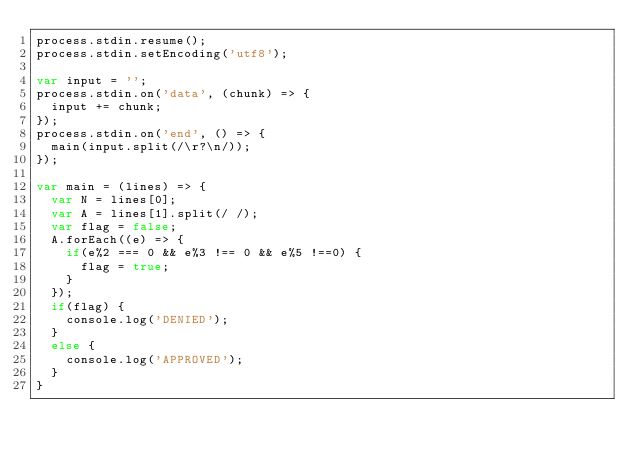<code> <loc_0><loc_0><loc_500><loc_500><_JavaScript_>process.stdin.resume();
process.stdin.setEncoding('utf8');

var input = '';
process.stdin.on('data', (chunk) => {
  input += chunk;
});
process.stdin.on('end', () => {
  main(input.split(/\r?\n/));
});

var main = (lines) => {
  var N = lines[0];
  var A = lines[1].split(/ /);
  var flag = false;
  A.forEach((e) => {
    if(e%2 === 0 && e%3 !== 0 && e%5 !==0) {
      flag = true;
    }
  });
  if(flag) {
    console.log('DENIED');
  }
  else {
    console.log('APPROVED');
  }
}</code> 